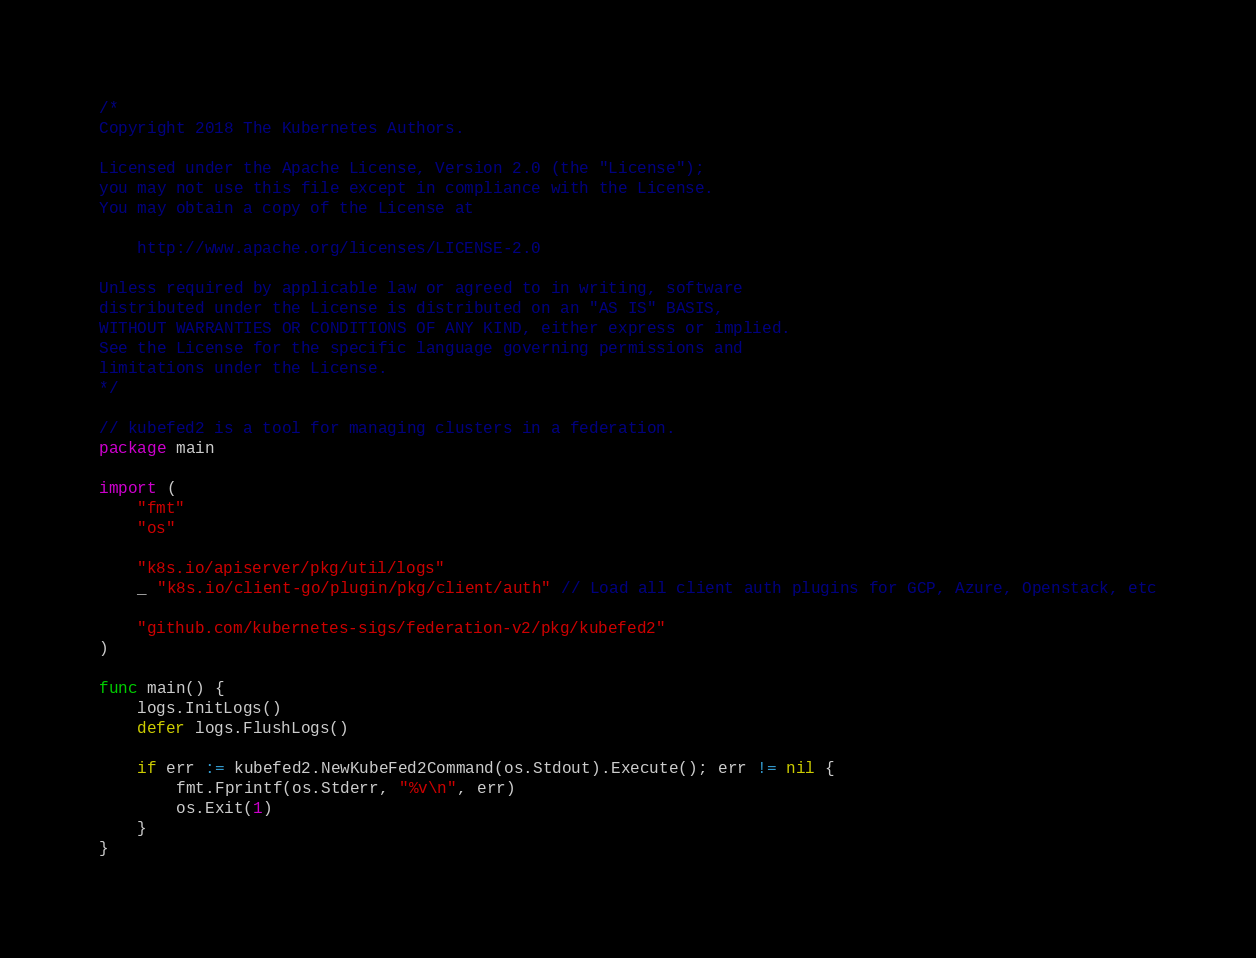Convert code to text. <code><loc_0><loc_0><loc_500><loc_500><_Go_>/*
Copyright 2018 The Kubernetes Authors.

Licensed under the Apache License, Version 2.0 (the "License");
you may not use this file except in compliance with the License.
You may obtain a copy of the License at

    http://www.apache.org/licenses/LICENSE-2.0

Unless required by applicable law or agreed to in writing, software
distributed under the License is distributed on an "AS IS" BASIS,
WITHOUT WARRANTIES OR CONDITIONS OF ANY KIND, either express or implied.
See the License for the specific language governing permissions and
limitations under the License.
*/

// kubefed2 is a tool for managing clusters in a federation.
package main

import (
	"fmt"
	"os"

	"k8s.io/apiserver/pkg/util/logs"
	_ "k8s.io/client-go/plugin/pkg/client/auth" // Load all client auth plugins for GCP, Azure, Openstack, etc

	"github.com/kubernetes-sigs/federation-v2/pkg/kubefed2"
)

func main() {
	logs.InitLogs()
	defer logs.FlushLogs()

	if err := kubefed2.NewKubeFed2Command(os.Stdout).Execute(); err != nil {
		fmt.Fprintf(os.Stderr, "%v\n", err)
		os.Exit(1)
	}
}
</code> 